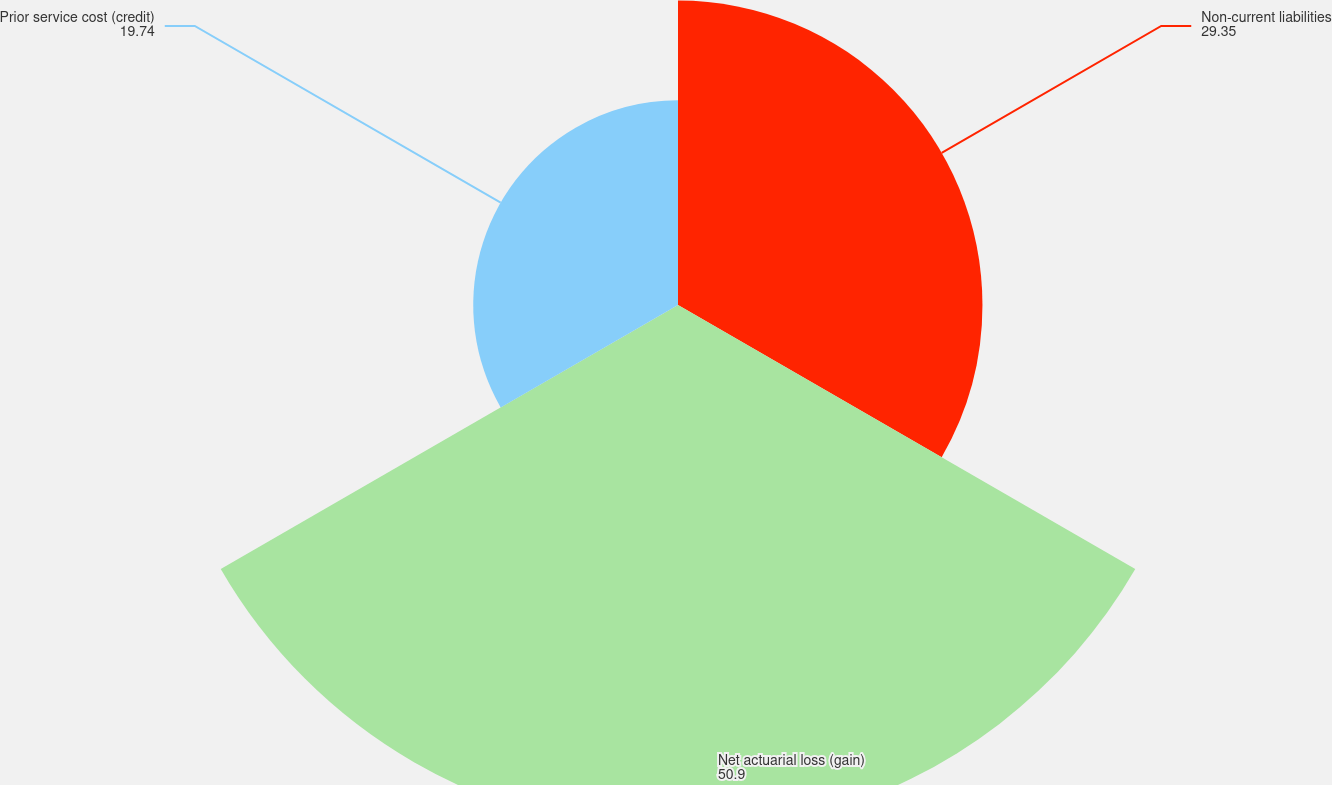Convert chart. <chart><loc_0><loc_0><loc_500><loc_500><pie_chart><fcel>Non-current liabilities<fcel>Net actuarial loss (gain)<fcel>Prior service cost (credit)<nl><fcel>29.35%<fcel>50.9%<fcel>19.74%<nl></chart> 